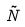<formula> <loc_0><loc_0><loc_500><loc_500>\tilde { N }</formula> 